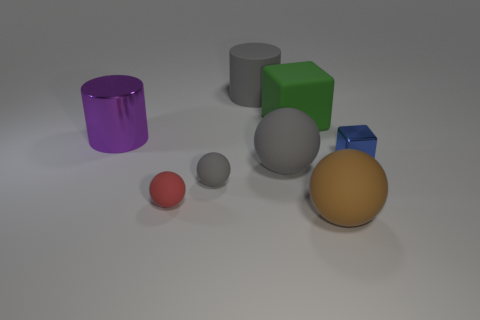Add 1 blue blocks. How many objects exist? 9 Subtract all cylinders. How many objects are left? 6 Add 3 small red things. How many small red things are left? 4 Add 4 brown objects. How many brown objects exist? 5 Subtract 1 blue cubes. How many objects are left? 7 Subtract all red matte balls. Subtract all large cubes. How many objects are left? 6 